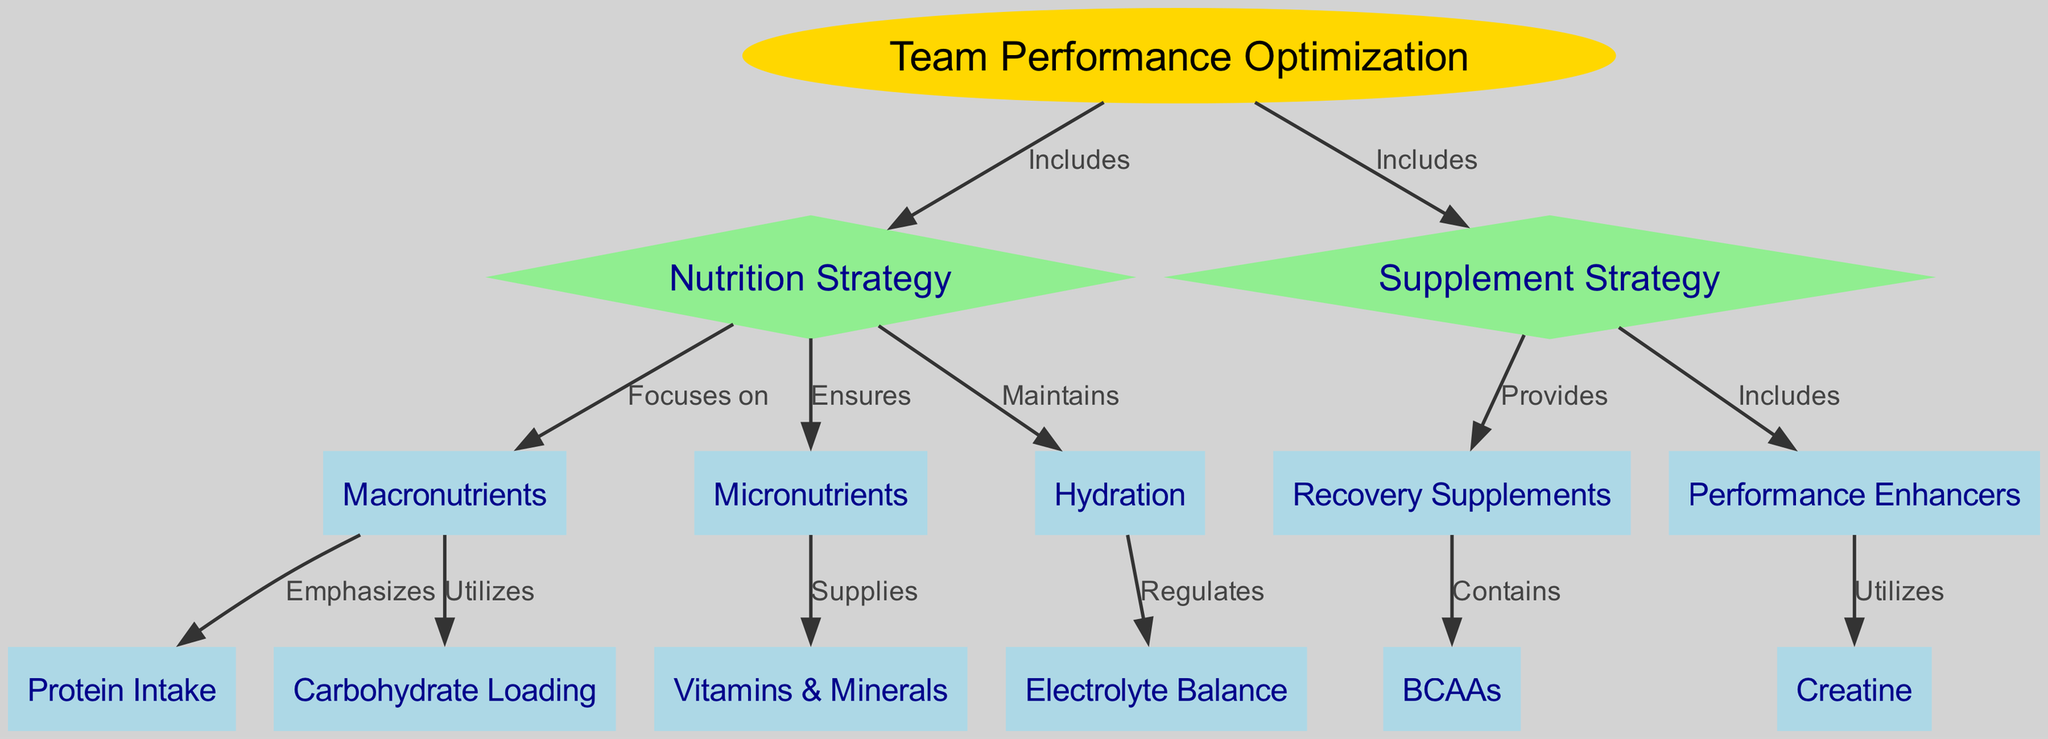What is the main focus of the diagram? The diagram centers on "Team Performance Optimization," which is the top node, indicating that all elements within it are geared towards enhancing team performance.
Answer: Team Performance Optimization How many nodes are in the diagram? By counting the total number of unique nodes listed in the data, I find that there are 14 nodes representing various strategies and components related to nutrition and supplements.
Answer: 14 What is included in the Nutrition Strategy? The Nutrition Strategy node directly includes "Macronutrients," "Micronutrients," and "Hydration," depicting the integral parts of a nutrition strategy aimed at performance optimization.
Answer: Macronutrients, Micronutrients, Hydration What do Recovery Supplements provide? According to the edges leading from the Recovery Supplements node, they contain "BCAAs," linking recovery supplements to branched-chain amino acids, which are important for recovery.
Answer: BCAAs Which strategy utilizes Creatine? The edge from the "Performance Enhancers" node to "Creatine" indicates that creatine is used as a performance-enhancing strategy, showing its relevance in optimizing performance.
Answer: Performance Enhancers What regulates Hydration in the context of the diagram? The relationship shown in the diagram reveals that Hydration has a regulatory function over "Electrolyte Balance," indicating that maintaining proper hydration is crucial for electrolyte management.
Answer: Electrolyte Balance What does Macronutrients emphasize? The edge leading from "Macronutrients" to "Protein Intake" indicates that protein intake is a key focus within the macronutrient strategy, which is fundamental for achieving optimal performance.
Answer: Protein Intake How does Supplement Strategy relate to Team Performance Optimization? The edges from the Team Performance Optimization node directly show that the Supplement Strategy is included in the overall optimization strategy, indicating its importance in enhancing performance.
Answer: Includes 